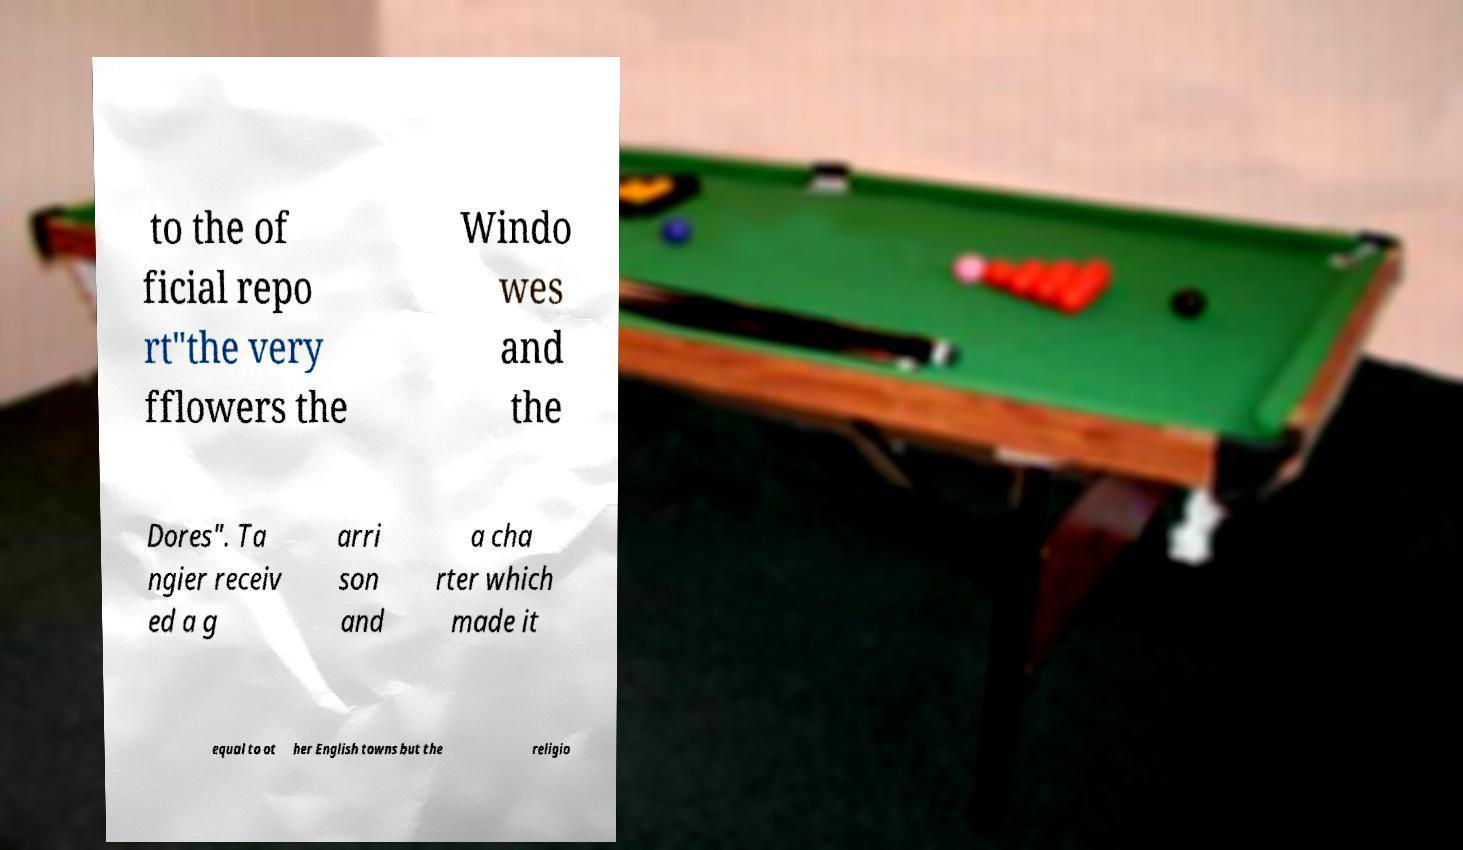There's text embedded in this image that I need extracted. Can you transcribe it verbatim? to the of ficial repo rt"the very fflowers the Windo wes and the Dores". Ta ngier receiv ed a g arri son and a cha rter which made it equal to ot her English towns but the religio 